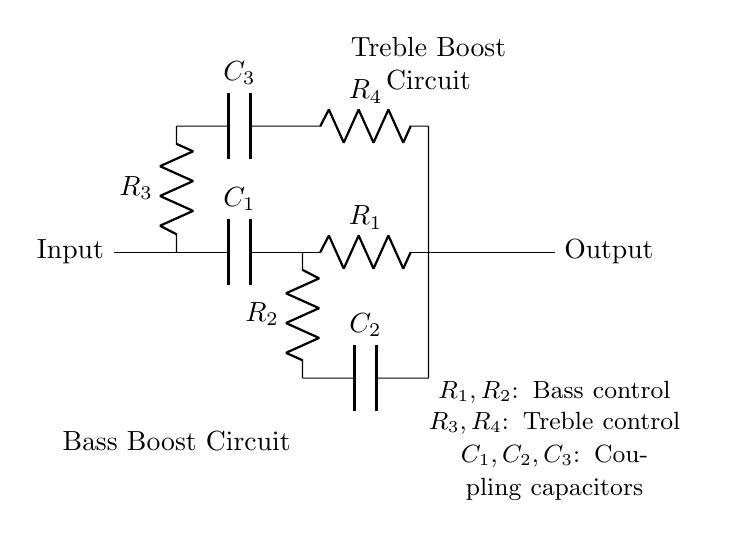What are the coupling capacitors in this circuit? The coupling capacitors are identified as C1, C2, and C3, which connect different stages of the circuit and allow AC signals to pass while blocking DC.
Answer: C1, C2, C3 What does R1 and R2 control in this circuit? R1 and R2 are responsible for the bass control within the circuit, adjusting the output level of the bass frequencies.
Answer: Bass control How many resistors are in total in this circuit? By counting all the resistors, R1, R2, R3, and R4, we find there are a total of four resistors in the circuit.
Answer: Four What does the node on the left labeled "Input" signify? The node on the left labeled "Input" indicates where the audio signal first enters the circuit before being processed for equalization.
Answer: Input Which part of the circuit is responsible for treble enhancement? The treble enhancement is handled by the upper part of the circuit, particularly with components R3, R4, and C3.
Answer: Treble Boost Circuit What is the overall function of this audio equalizer circuit? The overall function of this equalizer circuit is to enhance bass and treble frequencies to improve audio quality in vintage stereo systems.
Answer: Audio equalizer What is the function of the capacitors in this circuit? The capacitors, C1, C2, and C3, serve as coupling capacitors to block any DC component and allow the AC audio signal to pass through, crucial for maintaining audio integrity.
Answer: Coupling capacitors 